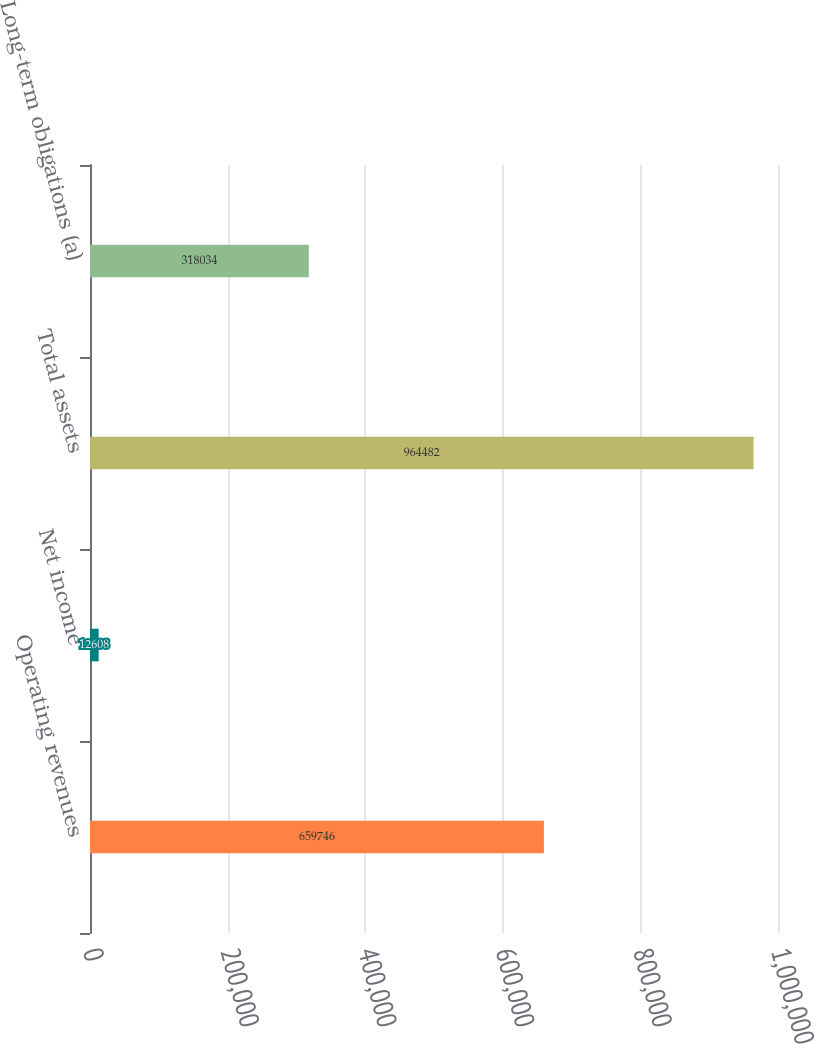Convert chart. <chart><loc_0><loc_0><loc_500><loc_500><bar_chart><fcel>Operating revenues<fcel>Net income<fcel>Total assets<fcel>Long-term obligations (a)<nl><fcel>659746<fcel>12608<fcel>964482<fcel>318034<nl></chart> 